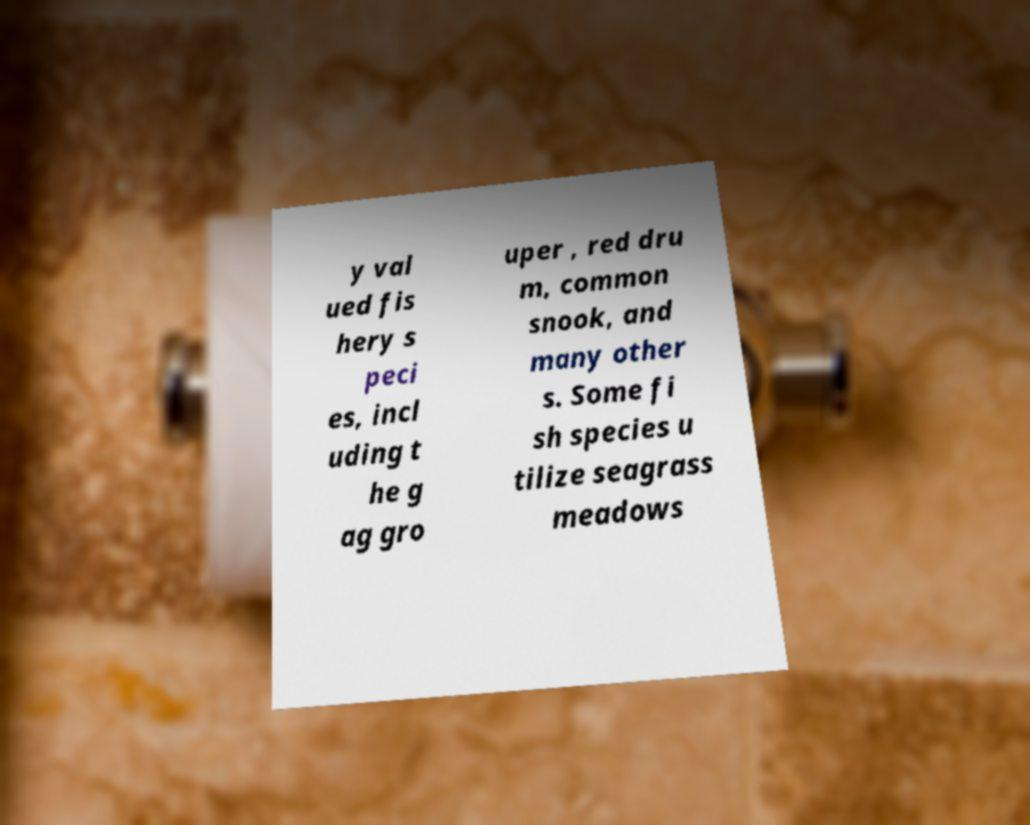Please identify and transcribe the text found in this image. y val ued fis hery s peci es, incl uding t he g ag gro uper , red dru m, common snook, and many other s. Some fi sh species u tilize seagrass meadows 